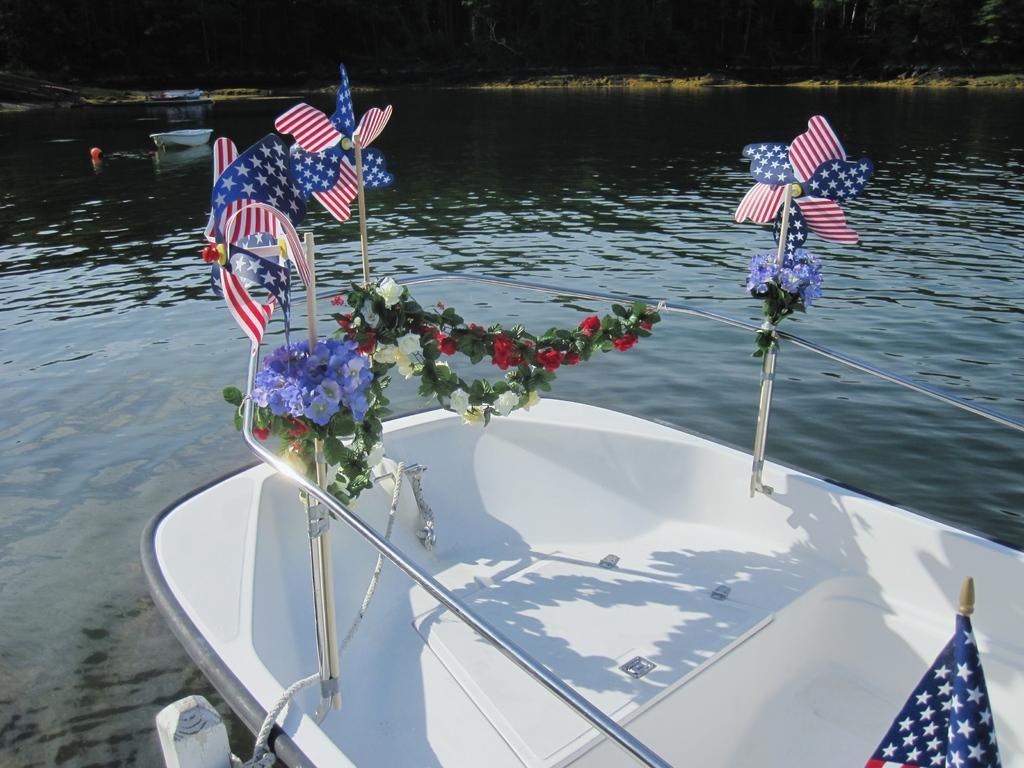Could you give a brief overview of what you see in this image? In this image, in the middle, we can see a boat which is drowning in the water. In the boat, we can see a flag, plant with some flowers and some flags. In the background, we can also see another boat, water in a lake, trees. 